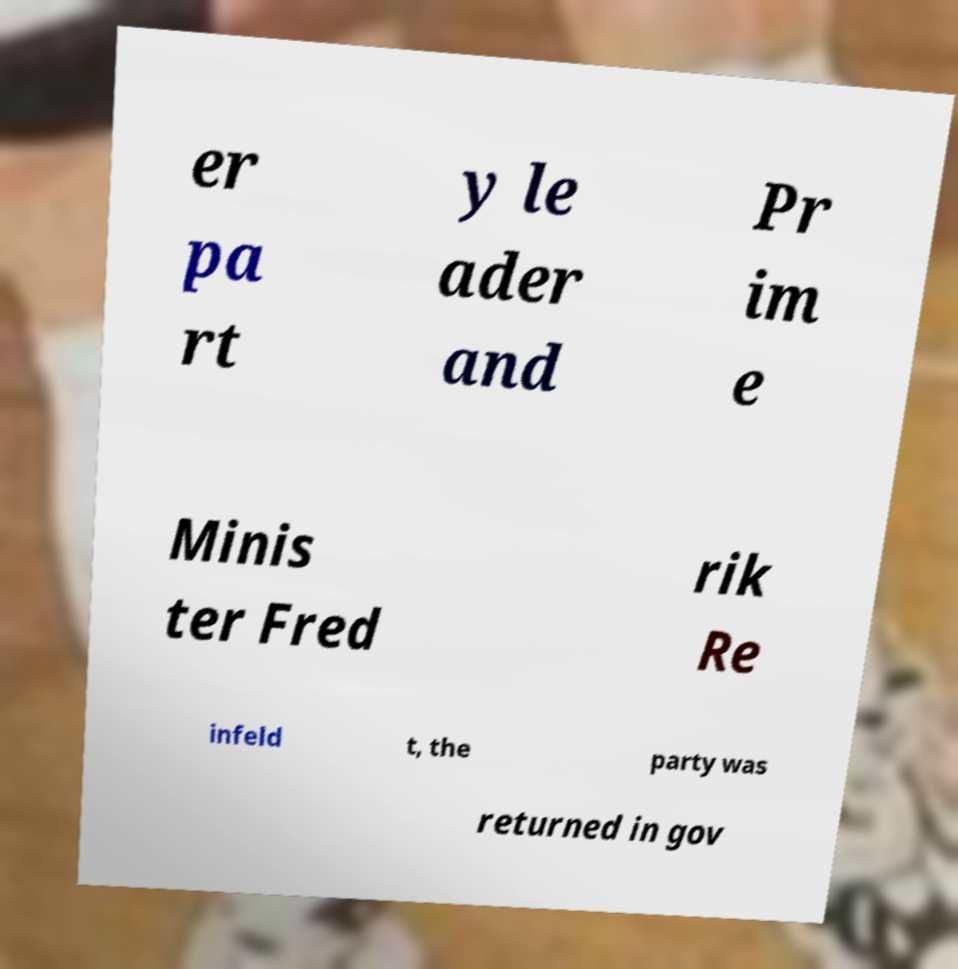I need the written content from this picture converted into text. Can you do that? er pa rt y le ader and Pr im e Minis ter Fred rik Re infeld t, the party was returned in gov 